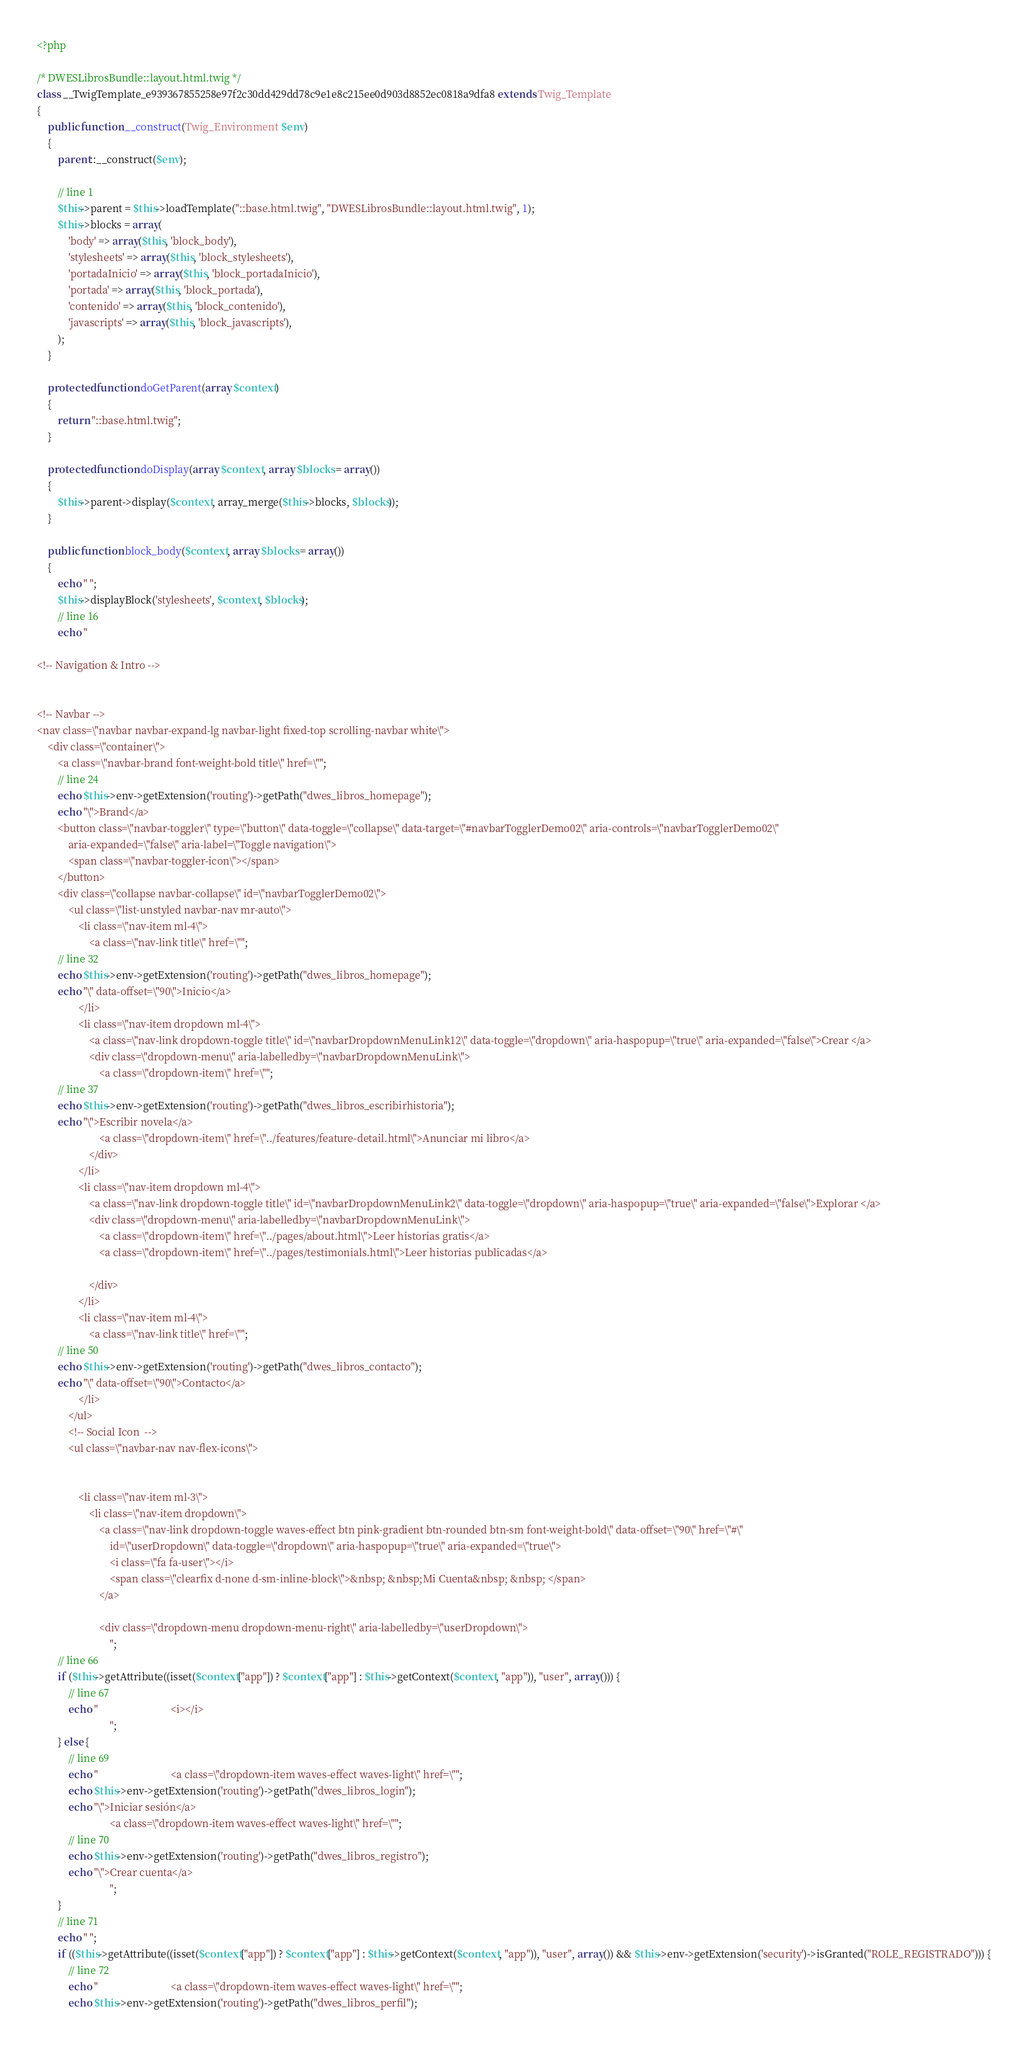<code> <loc_0><loc_0><loc_500><loc_500><_PHP_><?php

/* DWESLibrosBundle::layout.html.twig */
class __TwigTemplate_e939367855258e97f2c30dd429dd78c9e1e8c215ee0d903d8852ec0818a9dfa8 extends Twig_Template
{
    public function __construct(Twig_Environment $env)
    {
        parent::__construct($env);

        // line 1
        $this->parent = $this->loadTemplate("::base.html.twig", "DWESLibrosBundle::layout.html.twig", 1);
        $this->blocks = array(
            'body' => array($this, 'block_body'),
            'stylesheets' => array($this, 'block_stylesheets'),
            'portadaInicio' => array($this, 'block_portadaInicio'),
            'portada' => array($this, 'block_portada'),
            'contenido' => array($this, 'block_contenido'),
            'javascripts' => array($this, 'block_javascripts'),
        );
    }

    protected function doGetParent(array $context)
    {
        return "::base.html.twig";
    }

    protected function doDisplay(array $context, array $blocks = array())
    {
        $this->parent->display($context, array_merge($this->blocks, $blocks));
    }

    public function block_body($context, array $blocks = array())
    {
        echo " ";
        $this->displayBlock('stylesheets', $context, $blocks);
        // line 16
        echo "

<!-- Navigation & Intro -->


<!-- Navbar -->
<nav class=\"navbar navbar-expand-lg navbar-light fixed-top scrolling-navbar white\">
    <div class=\"container\">
        <a class=\"navbar-brand font-weight-bold title\" href=\"";
        // line 24
        echo $this->env->getExtension('routing')->getPath("dwes_libros_homepage");
        echo "\">Brand</a>
        <button class=\"navbar-toggler\" type=\"button\" data-toggle=\"collapse\" data-target=\"#navbarTogglerDemo02\" aria-controls=\"navbarTogglerDemo02\"
            aria-expanded=\"false\" aria-label=\"Toggle navigation\">
            <span class=\"navbar-toggler-icon\"></span>
        </button>
        <div class=\"collapse navbar-collapse\" id=\"navbarTogglerDemo02\">
            <ul class=\"list-unstyled navbar-nav mr-auto\">
                <li class=\"nav-item ml-4\">
                    <a class=\"nav-link title\" href=\"";
        // line 32
        echo $this->env->getExtension('routing')->getPath("dwes_libros_homepage");
        echo "\" data-offset=\"90\">Inicio</a>
                </li>
                <li class=\"nav-item dropdown ml-4\">
                    <a class=\"nav-link dropdown-toggle title\" id=\"navbarDropdownMenuLink12\" data-toggle=\"dropdown\" aria-haspopup=\"true\" aria-expanded=\"false\">Crear </a>
                    <div class=\"dropdown-menu\" aria-labelledby=\"navbarDropdownMenuLink\">
                        <a class=\"dropdown-item\" href=\"";
        // line 37
        echo $this->env->getExtension('routing')->getPath("dwes_libros_escribirhistoria");
        echo "\">Escribir novela</a>
                        <a class=\"dropdown-item\" href=\"../features/feature-detail.html\">Anunciar mi libro</a>
                    </div>
                </li>
                <li class=\"nav-item dropdown ml-4\">
                    <a class=\"nav-link dropdown-toggle title\" id=\"navbarDropdownMenuLink2\" data-toggle=\"dropdown\" aria-haspopup=\"true\" aria-expanded=\"false\">Explorar </a>
                    <div class=\"dropdown-menu\" aria-labelledby=\"navbarDropdownMenuLink\">
                        <a class=\"dropdown-item\" href=\"../pages/about.html\">Leer historias gratis</a>
                        <a class=\"dropdown-item\" href=\"../pages/testimonials.html\">Leer historias publicadas</a>

                    </div>
                </li>
                <li class=\"nav-item ml-4\">
                    <a class=\"nav-link title\" href=\"";
        // line 50
        echo $this->env->getExtension('routing')->getPath("dwes_libros_contacto");
        echo "\" data-offset=\"90\">Contacto</a>
                </li>
            </ul>
            <!-- Social Icon  -->
            <ul class=\"navbar-nav nav-flex-icons\">


                <li class=\"nav-item ml-3\">
                    <li class=\"nav-item dropdown\">
                        <a class=\"nav-link dropdown-toggle waves-effect btn pink-gradient btn-rounded btn-sm font-weight-bold\" data-offset=\"90\" href=\"#\"
                            id=\"userDropdown\" data-toggle=\"dropdown\" aria-haspopup=\"true\" aria-expanded=\"true\">
                            <i class=\"fa fa-user\"></i>
                            <span class=\"clearfix d-none d-sm-inline-block\">&nbsp; &nbsp;Mi Cuenta&nbsp; &nbsp; </span>
                        </a>

                        <div class=\"dropdown-menu dropdown-menu-right\" aria-labelledby=\"userDropdown\">
                            ";
        // line 66
        if ($this->getAttribute((isset($context["app"]) ? $context["app"] : $this->getContext($context, "app")), "user", array())) {
            // line 67
            echo "                            <i></i>
                            ";
        } else {
            // line 69
            echo "                            <a class=\"dropdown-item waves-effect waves-light\" href=\"";
            echo $this->env->getExtension('routing')->getPath("dwes_libros_login");
            echo "\">Iniciar sesión</a>
                            <a class=\"dropdown-item waves-effect waves-light\" href=\"";
            // line 70
            echo $this->env->getExtension('routing')->getPath("dwes_libros_registro");
            echo "\">Crear cuenta</a>
                            ";
        }
        // line 71
        echo " ";
        if (($this->getAttribute((isset($context["app"]) ? $context["app"] : $this->getContext($context, "app")), "user", array()) && $this->env->getExtension('security')->isGranted("ROLE_REGISTRADO"))) {
            // line 72
            echo "                            <a class=\"dropdown-item waves-effect waves-light\" href=\"";
            echo $this->env->getExtension('routing')->getPath("dwes_libros_perfil");</code> 